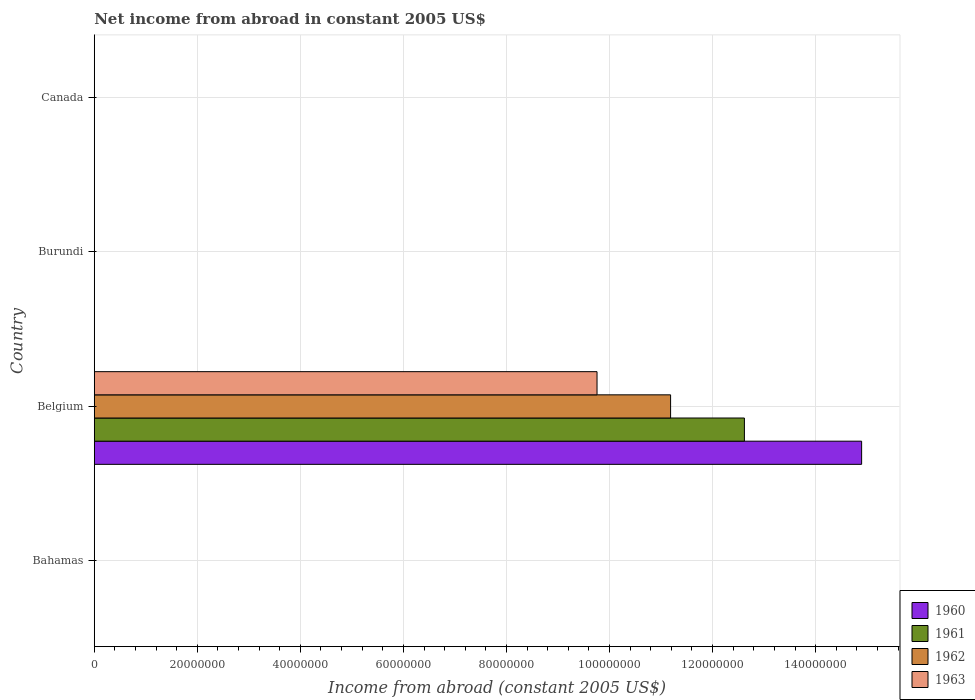How many different coloured bars are there?
Give a very brief answer. 4. Are the number of bars per tick equal to the number of legend labels?
Offer a very short reply. No. How many bars are there on the 4th tick from the bottom?
Your answer should be very brief. 0. In how many cases, is the number of bars for a given country not equal to the number of legend labels?
Your response must be concise. 3. What is the net income from abroad in 1960 in Burundi?
Offer a terse response. 0. Across all countries, what is the maximum net income from abroad in 1960?
Ensure brevity in your answer.  1.49e+08. Across all countries, what is the minimum net income from abroad in 1960?
Give a very brief answer. 0. In which country was the net income from abroad in 1963 maximum?
Provide a short and direct response. Belgium. What is the total net income from abroad in 1960 in the graph?
Your answer should be compact. 1.49e+08. What is the average net income from abroad in 1961 per country?
Your answer should be very brief. 3.15e+07. In how many countries, is the net income from abroad in 1963 greater than 92000000 US$?
Ensure brevity in your answer.  1. What is the difference between the highest and the lowest net income from abroad in 1962?
Provide a succinct answer. 1.12e+08. In how many countries, is the net income from abroad in 1960 greater than the average net income from abroad in 1960 taken over all countries?
Provide a short and direct response. 1. Is it the case that in every country, the sum of the net income from abroad in 1962 and net income from abroad in 1961 is greater than the net income from abroad in 1963?
Offer a terse response. No. How many bars are there?
Provide a succinct answer. 4. What is the difference between two consecutive major ticks on the X-axis?
Your response must be concise. 2.00e+07. Are the values on the major ticks of X-axis written in scientific E-notation?
Provide a short and direct response. No. How many legend labels are there?
Provide a short and direct response. 4. What is the title of the graph?
Your response must be concise. Net income from abroad in constant 2005 US$. Does "2011" appear as one of the legend labels in the graph?
Make the answer very short. No. What is the label or title of the X-axis?
Make the answer very short. Income from abroad (constant 2005 US$). What is the Income from abroad (constant 2005 US$) in 1962 in Bahamas?
Provide a succinct answer. 0. What is the Income from abroad (constant 2005 US$) of 1960 in Belgium?
Your answer should be very brief. 1.49e+08. What is the Income from abroad (constant 2005 US$) in 1961 in Belgium?
Ensure brevity in your answer.  1.26e+08. What is the Income from abroad (constant 2005 US$) of 1962 in Belgium?
Provide a short and direct response. 1.12e+08. What is the Income from abroad (constant 2005 US$) of 1963 in Belgium?
Keep it short and to the point. 9.76e+07. What is the Income from abroad (constant 2005 US$) of 1960 in Burundi?
Offer a terse response. 0. What is the Income from abroad (constant 2005 US$) in 1961 in Burundi?
Keep it short and to the point. 0. What is the Income from abroad (constant 2005 US$) of 1962 in Burundi?
Your answer should be compact. 0. What is the Income from abroad (constant 2005 US$) of 1963 in Burundi?
Your answer should be compact. 0. What is the Income from abroad (constant 2005 US$) in 1962 in Canada?
Offer a terse response. 0. What is the Income from abroad (constant 2005 US$) of 1963 in Canada?
Give a very brief answer. 0. Across all countries, what is the maximum Income from abroad (constant 2005 US$) in 1960?
Ensure brevity in your answer.  1.49e+08. Across all countries, what is the maximum Income from abroad (constant 2005 US$) in 1961?
Provide a short and direct response. 1.26e+08. Across all countries, what is the maximum Income from abroad (constant 2005 US$) in 1962?
Keep it short and to the point. 1.12e+08. Across all countries, what is the maximum Income from abroad (constant 2005 US$) of 1963?
Your answer should be very brief. 9.76e+07. Across all countries, what is the minimum Income from abroad (constant 2005 US$) in 1960?
Ensure brevity in your answer.  0. Across all countries, what is the minimum Income from abroad (constant 2005 US$) of 1961?
Keep it short and to the point. 0. Across all countries, what is the minimum Income from abroad (constant 2005 US$) in 1963?
Your answer should be very brief. 0. What is the total Income from abroad (constant 2005 US$) in 1960 in the graph?
Keep it short and to the point. 1.49e+08. What is the total Income from abroad (constant 2005 US$) in 1961 in the graph?
Give a very brief answer. 1.26e+08. What is the total Income from abroad (constant 2005 US$) in 1962 in the graph?
Provide a succinct answer. 1.12e+08. What is the total Income from abroad (constant 2005 US$) of 1963 in the graph?
Keep it short and to the point. 9.76e+07. What is the average Income from abroad (constant 2005 US$) of 1960 per country?
Provide a succinct answer. 3.72e+07. What is the average Income from abroad (constant 2005 US$) in 1961 per country?
Provide a succinct answer. 3.15e+07. What is the average Income from abroad (constant 2005 US$) in 1962 per country?
Keep it short and to the point. 2.80e+07. What is the average Income from abroad (constant 2005 US$) in 1963 per country?
Your response must be concise. 2.44e+07. What is the difference between the Income from abroad (constant 2005 US$) in 1960 and Income from abroad (constant 2005 US$) in 1961 in Belgium?
Provide a succinct answer. 2.27e+07. What is the difference between the Income from abroad (constant 2005 US$) of 1960 and Income from abroad (constant 2005 US$) of 1962 in Belgium?
Ensure brevity in your answer.  3.71e+07. What is the difference between the Income from abroad (constant 2005 US$) of 1960 and Income from abroad (constant 2005 US$) of 1963 in Belgium?
Offer a very short reply. 5.14e+07. What is the difference between the Income from abroad (constant 2005 US$) of 1961 and Income from abroad (constant 2005 US$) of 1962 in Belgium?
Your response must be concise. 1.43e+07. What is the difference between the Income from abroad (constant 2005 US$) of 1961 and Income from abroad (constant 2005 US$) of 1963 in Belgium?
Your response must be concise. 2.86e+07. What is the difference between the Income from abroad (constant 2005 US$) of 1962 and Income from abroad (constant 2005 US$) of 1963 in Belgium?
Your answer should be very brief. 1.43e+07. What is the difference between the highest and the lowest Income from abroad (constant 2005 US$) in 1960?
Your response must be concise. 1.49e+08. What is the difference between the highest and the lowest Income from abroad (constant 2005 US$) of 1961?
Offer a terse response. 1.26e+08. What is the difference between the highest and the lowest Income from abroad (constant 2005 US$) of 1962?
Offer a terse response. 1.12e+08. What is the difference between the highest and the lowest Income from abroad (constant 2005 US$) of 1963?
Offer a terse response. 9.76e+07. 